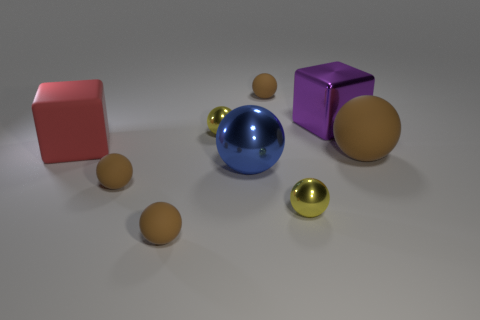How many brown spheres must be subtracted to get 1 brown spheres? 3 Subtract all cyan blocks. How many brown spheres are left? 4 Subtract all blue spheres. How many spheres are left? 6 Subtract all yellow metallic balls. How many balls are left? 5 Subtract all cyan spheres. Subtract all purple cubes. How many spheres are left? 7 Add 1 tiny spheres. How many objects exist? 10 Subtract all blocks. How many objects are left? 7 Add 2 large yellow shiny spheres. How many large yellow shiny spheres exist? 2 Subtract 0 gray cylinders. How many objects are left? 9 Subtract all large yellow shiny blocks. Subtract all spheres. How many objects are left? 2 